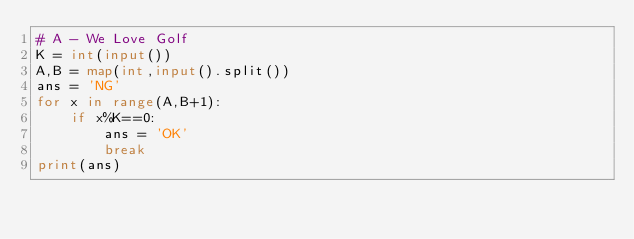<code> <loc_0><loc_0><loc_500><loc_500><_Python_># A - We Love Golf
K = int(input())
A,B = map(int,input().split())
ans = 'NG'
for x in range(A,B+1):
    if x%K==0:
        ans = 'OK'
        break
print(ans)</code> 